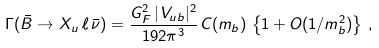Convert formula to latex. <formula><loc_0><loc_0><loc_500><loc_500>\Gamma ( \bar { B } \to X _ { u } \, \ell \, \bar { \nu } ) = { \frac { G _ { F } ^ { 2 } \, | \, V _ { u b } | ^ { 2 } } { 1 9 2 \pi ^ { 3 } } } \, C ( m _ { b } ) \, \left \{ 1 + O ( 1 / m _ { b } ^ { 2 } ) \right \} \, ,</formula> 